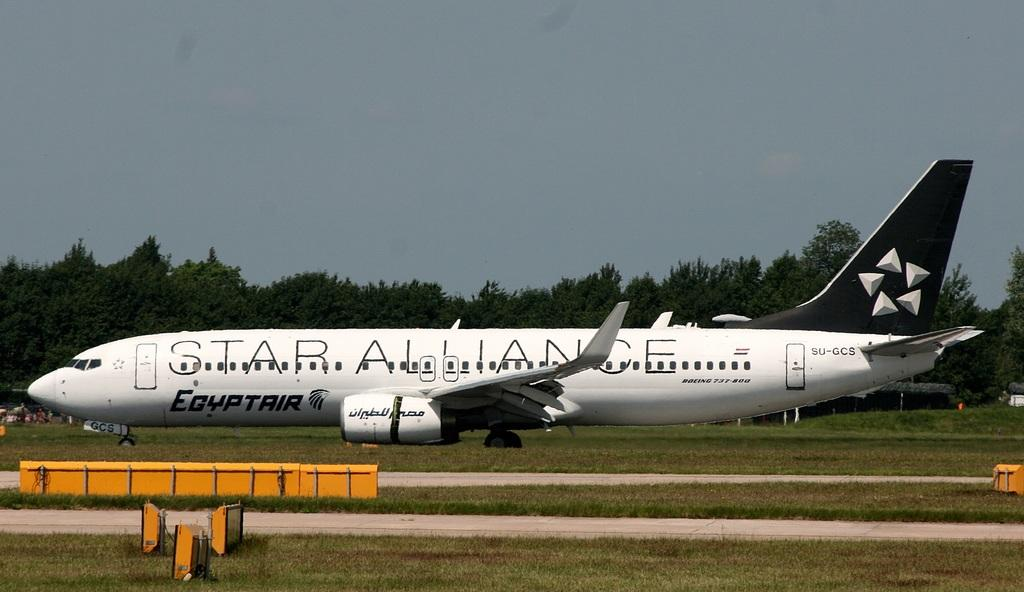<image>
Share a concise interpretation of the image provided. A large Egyptair airlines passenger aeroplane on the runway 